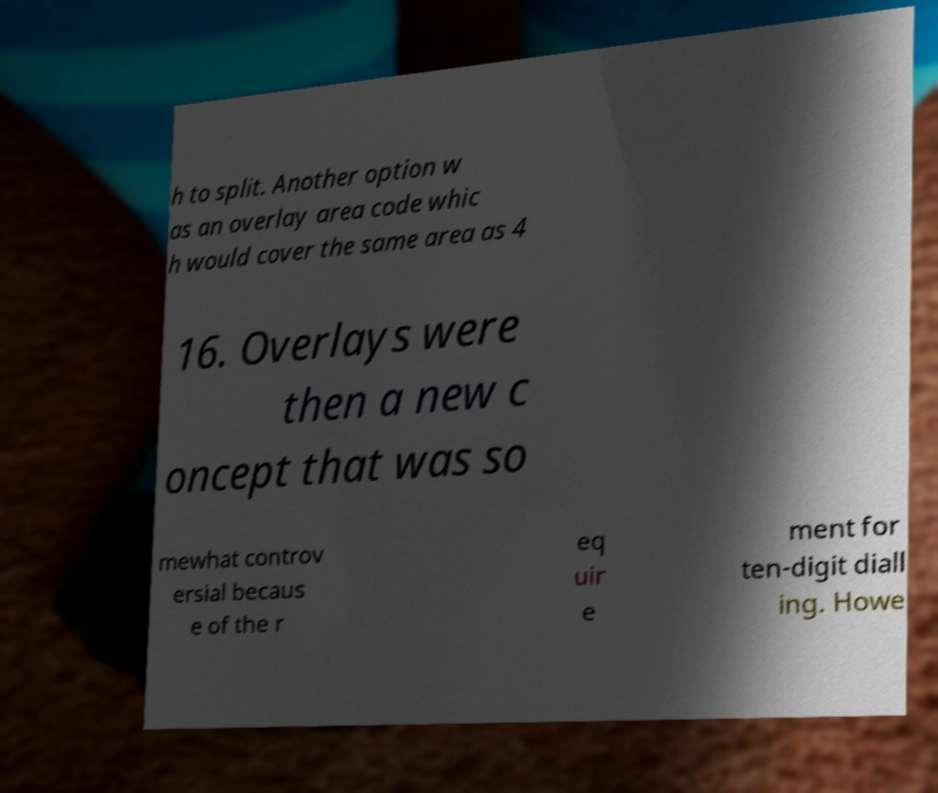I need the written content from this picture converted into text. Can you do that? h to split. Another option w as an overlay area code whic h would cover the same area as 4 16. Overlays were then a new c oncept that was so mewhat controv ersial becaus e of the r eq uir e ment for ten-digit diall ing. Howe 